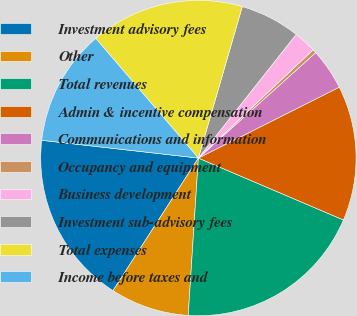Convert chart to OTSL. <chart><loc_0><loc_0><loc_500><loc_500><pie_chart><fcel>Investment advisory fees<fcel>Other<fcel>Total revenues<fcel>Admin & incentive compensation<fcel>Communications and information<fcel>Occupancy and equipment<fcel>Business development<fcel>Investment sub-advisory fees<fcel>Total expenses<fcel>Income before taxes and<nl><fcel>17.69%<fcel>8.08%<fcel>19.61%<fcel>13.84%<fcel>4.23%<fcel>0.39%<fcel>2.31%<fcel>6.16%<fcel>15.77%<fcel>11.92%<nl></chart> 